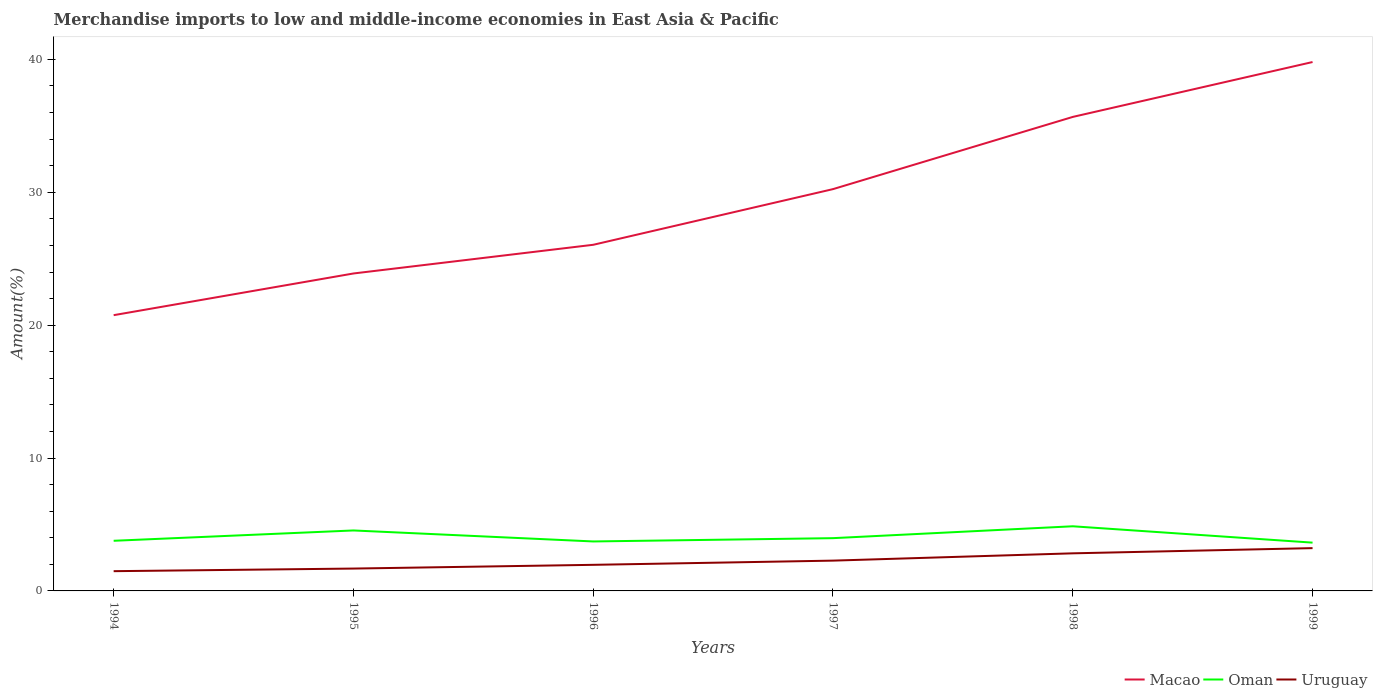Does the line corresponding to Macao intersect with the line corresponding to Uruguay?
Ensure brevity in your answer.  No. Across all years, what is the maximum percentage of amount earned from merchandise imports in Oman?
Give a very brief answer. 3.63. What is the total percentage of amount earned from merchandise imports in Macao in the graph?
Ensure brevity in your answer.  -9.56. What is the difference between the highest and the second highest percentage of amount earned from merchandise imports in Uruguay?
Provide a short and direct response. 1.73. What is the difference between the highest and the lowest percentage of amount earned from merchandise imports in Macao?
Your answer should be very brief. 3. Is the percentage of amount earned from merchandise imports in Oman strictly greater than the percentage of amount earned from merchandise imports in Macao over the years?
Offer a terse response. Yes. How many lines are there?
Offer a terse response. 3. What is the difference between two consecutive major ticks on the Y-axis?
Your response must be concise. 10. Are the values on the major ticks of Y-axis written in scientific E-notation?
Provide a succinct answer. No. Does the graph contain any zero values?
Your response must be concise. No. Where does the legend appear in the graph?
Give a very brief answer. Bottom right. How many legend labels are there?
Offer a terse response. 3. What is the title of the graph?
Offer a terse response. Merchandise imports to low and middle-income economies in East Asia & Pacific. What is the label or title of the X-axis?
Offer a very short reply. Years. What is the label or title of the Y-axis?
Ensure brevity in your answer.  Amount(%). What is the Amount(%) of Macao in 1994?
Offer a terse response. 20.75. What is the Amount(%) in Oman in 1994?
Offer a terse response. 3.77. What is the Amount(%) of Uruguay in 1994?
Offer a terse response. 1.49. What is the Amount(%) in Macao in 1995?
Your answer should be very brief. 23.89. What is the Amount(%) in Oman in 1995?
Offer a very short reply. 4.55. What is the Amount(%) of Uruguay in 1995?
Your response must be concise. 1.68. What is the Amount(%) of Macao in 1996?
Offer a terse response. 26.05. What is the Amount(%) of Oman in 1996?
Provide a short and direct response. 3.72. What is the Amount(%) in Uruguay in 1996?
Offer a very short reply. 1.96. What is the Amount(%) in Macao in 1997?
Your answer should be compact. 30.24. What is the Amount(%) in Oman in 1997?
Offer a very short reply. 3.97. What is the Amount(%) in Uruguay in 1997?
Ensure brevity in your answer.  2.28. What is the Amount(%) of Macao in 1998?
Your answer should be very brief. 35.67. What is the Amount(%) in Oman in 1998?
Give a very brief answer. 4.86. What is the Amount(%) of Uruguay in 1998?
Your answer should be very brief. 2.83. What is the Amount(%) in Macao in 1999?
Offer a very short reply. 39.8. What is the Amount(%) of Oman in 1999?
Offer a very short reply. 3.63. What is the Amount(%) in Uruguay in 1999?
Your response must be concise. 3.22. Across all years, what is the maximum Amount(%) of Macao?
Your response must be concise. 39.8. Across all years, what is the maximum Amount(%) in Oman?
Offer a very short reply. 4.86. Across all years, what is the maximum Amount(%) in Uruguay?
Give a very brief answer. 3.22. Across all years, what is the minimum Amount(%) in Macao?
Ensure brevity in your answer.  20.75. Across all years, what is the minimum Amount(%) in Oman?
Give a very brief answer. 3.63. Across all years, what is the minimum Amount(%) in Uruguay?
Ensure brevity in your answer.  1.49. What is the total Amount(%) of Macao in the graph?
Give a very brief answer. 176.4. What is the total Amount(%) of Oman in the graph?
Provide a succinct answer. 24.52. What is the total Amount(%) in Uruguay in the graph?
Provide a short and direct response. 13.46. What is the difference between the Amount(%) in Macao in 1994 and that in 1995?
Offer a terse response. -3.14. What is the difference between the Amount(%) in Oman in 1994 and that in 1995?
Ensure brevity in your answer.  -0.78. What is the difference between the Amount(%) of Uruguay in 1994 and that in 1995?
Offer a terse response. -0.2. What is the difference between the Amount(%) in Macao in 1994 and that in 1996?
Your answer should be compact. -5.3. What is the difference between the Amount(%) in Oman in 1994 and that in 1996?
Keep it short and to the point. 0.05. What is the difference between the Amount(%) in Uruguay in 1994 and that in 1996?
Ensure brevity in your answer.  -0.48. What is the difference between the Amount(%) in Macao in 1994 and that in 1997?
Ensure brevity in your answer.  -9.49. What is the difference between the Amount(%) in Oman in 1994 and that in 1997?
Provide a short and direct response. -0.2. What is the difference between the Amount(%) in Uruguay in 1994 and that in 1997?
Your answer should be very brief. -0.79. What is the difference between the Amount(%) of Macao in 1994 and that in 1998?
Make the answer very short. -14.92. What is the difference between the Amount(%) of Oman in 1994 and that in 1998?
Your answer should be compact. -1.09. What is the difference between the Amount(%) of Uruguay in 1994 and that in 1998?
Provide a succinct answer. -1.34. What is the difference between the Amount(%) in Macao in 1994 and that in 1999?
Provide a succinct answer. -19.05. What is the difference between the Amount(%) in Oman in 1994 and that in 1999?
Your response must be concise. 0.14. What is the difference between the Amount(%) of Uruguay in 1994 and that in 1999?
Make the answer very short. -1.73. What is the difference between the Amount(%) in Macao in 1995 and that in 1996?
Offer a very short reply. -2.16. What is the difference between the Amount(%) in Oman in 1995 and that in 1996?
Ensure brevity in your answer.  0.83. What is the difference between the Amount(%) of Uruguay in 1995 and that in 1996?
Your answer should be compact. -0.28. What is the difference between the Amount(%) of Macao in 1995 and that in 1997?
Make the answer very short. -6.35. What is the difference between the Amount(%) in Oman in 1995 and that in 1997?
Provide a succinct answer. 0.58. What is the difference between the Amount(%) of Uruguay in 1995 and that in 1997?
Your response must be concise. -0.6. What is the difference between the Amount(%) of Macao in 1995 and that in 1998?
Keep it short and to the point. -11.78. What is the difference between the Amount(%) in Oman in 1995 and that in 1998?
Keep it short and to the point. -0.31. What is the difference between the Amount(%) of Uruguay in 1995 and that in 1998?
Offer a very short reply. -1.15. What is the difference between the Amount(%) of Macao in 1995 and that in 1999?
Offer a very short reply. -15.91. What is the difference between the Amount(%) in Oman in 1995 and that in 1999?
Offer a very short reply. 0.92. What is the difference between the Amount(%) in Uruguay in 1995 and that in 1999?
Your answer should be very brief. -1.54. What is the difference between the Amount(%) in Macao in 1996 and that in 1997?
Ensure brevity in your answer.  -4.19. What is the difference between the Amount(%) of Oman in 1996 and that in 1997?
Provide a short and direct response. -0.25. What is the difference between the Amount(%) in Uruguay in 1996 and that in 1997?
Offer a very short reply. -0.32. What is the difference between the Amount(%) of Macao in 1996 and that in 1998?
Ensure brevity in your answer.  -9.62. What is the difference between the Amount(%) in Oman in 1996 and that in 1998?
Ensure brevity in your answer.  -1.14. What is the difference between the Amount(%) in Uruguay in 1996 and that in 1998?
Offer a terse response. -0.86. What is the difference between the Amount(%) in Macao in 1996 and that in 1999?
Provide a succinct answer. -13.75. What is the difference between the Amount(%) of Oman in 1996 and that in 1999?
Provide a short and direct response. 0.09. What is the difference between the Amount(%) of Uruguay in 1996 and that in 1999?
Ensure brevity in your answer.  -1.26. What is the difference between the Amount(%) of Macao in 1997 and that in 1998?
Your response must be concise. -5.43. What is the difference between the Amount(%) of Oman in 1997 and that in 1998?
Your response must be concise. -0.89. What is the difference between the Amount(%) of Uruguay in 1997 and that in 1998?
Your answer should be compact. -0.55. What is the difference between the Amount(%) of Macao in 1997 and that in 1999?
Your answer should be compact. -9.56. What is the difference between the Amount(%) in Oman in 1997 and that in 1999?
Your answer should be compact. 0.34. What is the difference between the Amount(%) in Uruguay in 1997 and that in 1999?
Provide a succinct answer. -0.94. What is the difference between the Amount(%) of Macao in 1998 and that in 1999?
Provide a succinct answer. -4.13. What is the difference between the Amount(%) of Oman in 1998 and that in 1999?
Your response must be concise. 1.23. What is the difference between the Amount(%) of Uruguay in 1998 and that in 1999?
Give a very brief answer. -0.39. What is the difference between the Amount(%) in Macao in 1994 and the Amount(%) in Oman in 1995?
Keep it short and to the point. 16.2. What is the difference between the Amount(%) in Macao in 1994 and the Amount(%) in Uruguay in 1995?
Ensure brevity in your answer.  19.07. What is the difference between the Amount(%) of Oman in 1994 and the Amount(%) of Uruguay in 1995?
Your answer should be compact. 2.09. What is the difference between the Amount(%) of Macao in 1994 and the Amount(%) of Oman in 1996?
Keep it short and to the point. 17.03. What is the difference between the Amount(%) in Macao in 1994 and the Amount(%) in Uruguay in 1996?
Make the answer very short. 18.79. What is the difference between the Amount(%) in Oman in 1994 and the Amount(%) in Uruguay in 1996?
Give a very brief answer. 1.81. What is the difference between the Amount(%) in Macao in 1994 and the Amount(%) in Oman in 1997?
Provide a short and direct response. 16.78. What is the difference between the Amount(%) in Macao in 1994 and the Amount(%) in Uruguay in 1997?
Provide a short and direct response. 18.47. What is the difference between the Amount(%) of Oman in 1994 and the Amount(%) of Uruguay in 1997?
Offer a very short reply. 1.49. What is the difference between the Amount(%) of Macao in 1994 and the Amount(%) of Oman in 1998?
Your answer should be compact. 15.89. What is the difference between the Amount(%) in Macao in 1994 and the Amount(%) in Uruguay in 1998?
Keep it short and to the point. 17.92. What is the difference between the Amount(%) of Oman in 1994 and the Amount(%) of Uruguay in 1998?
Keep it short and to the point. 0.95. What is the difference between the Amount(%) of Macao in 1994 and the Amount(%) of Oman in 1999?
Keep it short and to the point. 17.12. What is the difference between the Amount(%) in Macao in 1994 and the Amount(%) in Uruguay in 1999?
Your answer should be very brief. 17.53. What is the difference between the Amount(%) in Oman in 1994 and the Amount(%) in Uruguay in 1999?
Your answer should be very brief. 0.55. What is the difference between the Amount(%) in Macao in 1995 and the Amount(%) in Oman in 1996?
Provide a succinct answer. 20.17. What is the difference between the Amount(%) of Macao in 1995 and the Amount(%) of Uruguay in 1996?
Provide a short and direct response. 21.92. What is the difference between the Amount(%) in Oman in 1995 and the Amount(%) in Uruguay in 1996?
Provide a succinct answer. 2.59. What is the difference between the Amount(%) of Macao in 1995 and the Amount(%) of Oman in 1997?
Make the answer very short. 19.92. What is the difference between the Amount(%) in Macao in 1995 and the Amount(%) in Uruguay in 1997?
Your answer should be compact. 21.61. What is the difference between the Amount(%) of Oman in 1995 and the Amount(%) of Uruguay in 1997?
Keep it short and to the point. 2.27. What is the difference between the Amount(%) of Macao in 1995 and the Amount(%) of Oman in 1998?
Ensure brevity in your answer.  19.02. What is the difference between the Amount(%) in Macao in 1995 and the Amount(%) in Uruguay in 1998?
Make the answer very short. 21.06. What is the difference between the Amount(%) in Oman in 1995 and the Amount(%) in Uruguay in 1998?
Keep it short and to the point. 1.72. What is the difference between the Amount(%) of Macao in 1995 and the Amount(%) of Oman in 1999?
Your response must be concise. 20.25. What is the difference between the Amount(%) of Macao in 1995 and the Amount(%) of Uruguay in 1999?
Keep it short and to the point. 20.67. What is the difference between the Amount(%) of Oman in 1995 and the Amount(%) of Uruguay in 1999?
Your response must be concise. 1.33. What is the difference between the Amount(%) of Macao in 1996 and the Amount(%) of Oman in 1997?
Provide a succinct answer. 22.08. What is the difference between the Amount(%) in Macao in 1996 and the Amount(%) in Uruguay in 1997?
Keep it short and to the point. 23.77. What is the difference between the Amount(%) in Oman in 1996 and the Amount(%) in Uruguay in 1997?
Your answer should be compact. 1.44. What is the difference between the Amount(%) in Macao in 1996 and the Amount(%) in Oman in 1998?
Your answer should be very brief. 21.18. What is the difference between the Amount(%) in Macao in 1996 and the Amount(%) in Uruguay in 1998?
Offer a terse response. 23.22. What is the difference between the Amount(%) in Oman in 1996 and the Amount(%) in Uruguay in 1998?
Make the answer very short. 0.89. What is the difference between the Amount(%) of Macao in 1996 and the Amount(%) of Oman in 1999?
Make the answer very short. 22.41. What is the difference between the Amount(%) of Macao in 1996 and the Amount(%) of Uruguay in 1999?
Your response must be concise. 22.83. What is the difference between the Amount(%) in Oman in 1996 and the Amount(%) in Uruguay in 1999?
Your answer should be compact. 0.5. What is the difference between the Amount(%) of Macao in 1997 and the Amount(%) of Oman in 1998?
Provide a short and direct response. 25.37. What is the difference between the Amount(%) of Macao in 1997 and the Amount(%) of Uruguay in 1998?
Provide a succinct answer. 27.41. What is the difference between the Amount(%) of Oman in 1997 and the Amount(%) of Uruguay in 1998?
Provide a short and direct response. 1.14. What is the difference between the Amount(%) of Macao in 1997 and the Amount(%) of Oman in 1999?
Ensure brevity in your answer.  26.6. What is the difference between the Amount(%) of Macao in 1997 and the Amount(%) of Uruguay in 1999?
Offer a terse response. 27.02. What is the difference between the Amount(%) of Oman in 1997 and the Amount(%) of Uruguay in 1999?
Provide a short and direct response. 0.75. What is the difference between the Amount(%) of Macao in 1998 and the Amount(%) of Oman in 1999?
Give a very brief answer. 32.04. What is the difference between the Amount(%) in Macao in 1998 and the Amount(%) in Uruguay in 1999?
Give a very brief answer. 32.45. What is the difference between the Amount(%) of Oman in 1998 and the Amount(%) of Uruguay in 1999?
Your response must be concise. 1.64. What is the average Amount(%) in Macao per year?
Offer a terse response. 29.4. What is the average Amount(%) in Oman per year?
Provide a short and direct response. 4.09. What is the average Amount(%) of Uruguay per year?
Offer a terse response. 2.24. In the year 1994, what is the difference between the Amount(%) of Macao and Amount(%) of Oman?
Offer a very short reply. 16.98. In the year 1994, what is the difference between the Amount(%) in Macao and Amount(%) in Uruguay?
Keep it short and to the point. 19.27. In the year 1994, what is the difference between the Amount(%) of Oman and Amount(%) of Uruguay?
Your answer should be compact. 2.29. In the year 1995, what is the difference between the Amount(%) of Macao and Amount(%) of Oman?
Provide a short and direct response. 19.34. In the year 1995, what is the difference between the Amount(%) of Macao and Amount(%) of Uruguay?
Offer a very short reply. 22.21. In the year 1995, what is the difference between the Amount(%) of Oman and Amount(%) of Uruguay?
Offer a terse response. 2.87. In the year 1996, what is the difference between the Amount(%) of Macao and Amount(%) of Oman?
Your answer should be very brief. 22.32. In the year 1996, what is the difference between the Amount(%) in Macao and Amount(%) in Uruguay?
Make the answer very short. 24.08. In the year 1996, what is the difference between the Amount(%) of Oman and Amount(%) of Uruguay?
Ensure brevity in your answer.  1.76. In the year 1997, what is the difference between the Amount(%) in Macao and Amount(%) in Oman?
Ensure brevity in your answer.  26.27. In the year 1997, what is the difference between the Amount(%) of Macao and Amount(%) of Uruguay?
Provide a short and direct response. 27.96. In the year 1997, what is the difference between the Amount(%) of Oman and Amount(%) of Uruguay?
Your response must be concise. 1.69. In the year 1998, what is the difference between the Amount(%) of Macao and Amount(%) of Oman?
Provide a succinct answer. 30.81. In the year 1998, what is the difference between the Amount(%) of Macao and Amount(%) of Uruguay?
Your answer should be compact. 32.84. In the year 1998, what is the difference between the Amount(%) in Oman and Amount(%) in Uruguay?
Give a very brief answer. 2.04. In the year 1999, what is the difference between the Amount(%) of Macao and Amount(%) of Oman?
Offer a very short reply. 36.17. In the year 1999, what is the difference between the Amount(%) of Macao and Amount(%) of Uruguay?
Make the answer very short. 36.58. In the year 1999, what is the difference between the Amount(%) of Oman and Amount(%) of Uruguay?
Provide a short and direct response. 0.41. What is the ratio of the Amount(%) of Macao in 1994 to that in 1995?
Your answer should be compact. 0.87. What is the ratio of the Amount(%) in Oman in 1994 to that in 1995?
Make the answer very short. 0.83. What is the ratio of the Amount(%) in Uruguay in 1994 to that in 1995?
Provide a succinct answer. 0.88. What is the ratio of the Amount(%) in Macao in 1994 to that in 1996?
Your answer should be very brief. 0.8. What is the ratio of the Amount(%) of Oman in 1994 to that in 1996?
Offer a very short reply. 1.01. What is the ratio of the Amount(%) in Uruguay in 1994 to that in 1996?
Provide a short and direct response. 0.76. What is the ratio of the Amount(%) of Macao in 1994 to that in 1997?
Ensure brevity in your answer.  0.69. What is the ratio of the Amount(%) in Oman in 1994 to that in 1997?
Your answer should be compact. 0.95. What is the ratio of the Amount(%) in Uruguay in 1994 to that in 1997?
Your answer should be very brief. 0.65. What is the ratio of the Amount(%) in Macao in 1994 to that in 1998?
Provide a short and direct response. 0.58. What is the ratio of the Amount(%) in Oman in 1994 to that in 1998?
Offer a very short reply. 0.78. What is the ratio of the Amount(%) in Uruguay in 1994 to that in 1998?
Your response must be concise. 0.53. What is the ratio of the Amount(%) of Macao in 1994 to that in 1999?
Provide a succinct answer. 0.52. What is the ratio of the Amount(%) in Uruguay in 1994 to that in 1999?
Your answer should be compact. 0.46. What is the ratio of the Amount(%) of Macao in 1995 to that in 1996?
Your answer should be compact. 0.92. What is the ratio of the Amount(%) of Oman in 1995 to that in 1996?
Provide a succinct answer. 1.22. What is the ratio of the Amount(%) in Uruguay in 1995 to that in 1996?
Your answer should be very brief. 0.86. What is the ratio of the Amount(%) in Macao in 1995 to that in 1997?
Provide a short and direct response. 0.79. What is the ratio of the Amount(%) of Oman in 1995 to that in 1997?
Make the answer very short. 1.15. What is the ratio of the Amount(%) of Uruguay in 1995 to that in 1997?
Keep it short and to the point. 0.74. What is the ratio of the Amount(%) in Macao in 1995 to that in 1998?
Keep it short and to the point. 0.67. What is the ratio of the Amount(%) of Oman in 1995 to that in 1998?
Your answer should be compact. 0.94. What is the ratio of the Amount(%) of Uruguay in 1995 to that in 1998?
Your response must be concise. 0.59. What is the ratio of the Amount(%) of Macao in 1995 to that in 1999?
Make the answer very short. 0.6. What is the ratio of the Amount(%) of Oman in 1995 to that in 1999?
Your answer should be compact. 1.25. What is the ratio of the Amount(%) in Uruguay in 1995 to that in 1999?
Offer a terse response. 0.52. What is the ratio of the Amount(%) of Macao in 1996 to that in 1997?
Provide a short and direct response. 0.86. What is the ratio of the Amount(%) in Uruguay in 1996 to that in 1997?
Keep it short and to the point. 0.86. What is the ratio of the Amount(%) in Macao in 1996 to that in 1998?
Your answer should be very brief. 0.73. What is the ratio of the Amount(%) in Oman in 1996 to that in 1998?
Your answer should be very brief. 0.77. What is the ratio of the Amount(%) of Uruguay in 1996 to that in 1998?
Keep it short and to the point. 0.69. What is the ratio of the Amount(%) in Macao in 1996 to that in 1999?
Ensure brevity in your answer.  0.65. What is the ratio of the Amount(%) of Oman in 1996 to that in 1999?
Provide a short and direct response. 1.02. What is the ratio of the Amount(%) in Uruguay in 1996 to that in 1999?
Provide a short and direct response. 0.61. What is the ratio of the Amount(%) in Macao in 1997 to that in 1998?
Give a very brief answer. 0.85. What is the ratio of the Amount(%) in Oman in 1997 to that in 1998?
Ensure brevity in your answer.  0.82. What is the ratio of the Amount(%) of Uruguay in 1997 to that in 1998?
Your answer should be very brief. 0.81. What is the ratio of the Amount(%) in Macao in 1997 to that in 1999?
Keep it short and to the point. 0.76. What is the ratio of the Amount(%) in Oman in 1997 to that in 1999?
Provide a short and direct response. 1.09. What is the ratio of the Amount(%) of Uruguay in 1997 to that in 1999?
Provide a short and direct response. 0.71. What is the ratio of the Amount(%) of Macao in 1998 to that in 1999?
Provide a succinct answer. 0.9. What is the ratio of the Amount(%) of Oman in 1998 to that in 1999?
Ensure brevity in your answer.  1.34. What is the ratio of the Amount(%) of Uruguay in 1998 to that in 1999?
Make the answer very short. 0.88. What is the difference between the highest and the second highest Amount(%) of Macao?
Provide a short and direct response. 4.13. What is the difference between the highest and the second highest Amount(%) of Oman?
Ensure brevity in your answer.  0.31. What is the difference between the highest and the second highest Amount(%) of Uruguay?
Offer a terse response. 0.39. What is the difference between the highest and the lowest Amount(%) of Macao?
Your answer should be compact. 19.05. What is the difference between the highest and the lowest Amount(%) in Oman?
Keep it short and to the point. 1.23. What is the difference between the highest and the lowest Amount(%) in Uruguay?
Make the answer very short. 1.73. 